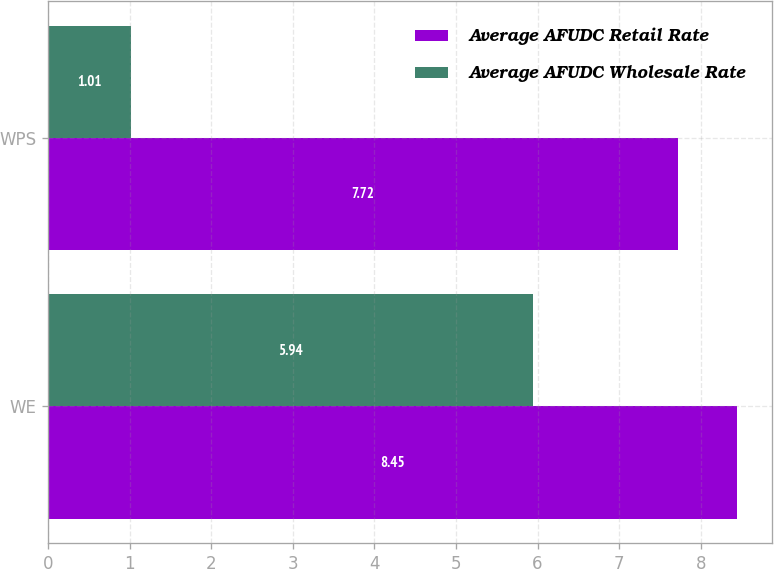<chart> <loc_0><loc_0><loc_500><loc_500><stacked_bar_chart><ecel><fcel>WE<fcel>WPS<nl><fcel>Average AFUDC Retail Rate<fcel>8.45<fcel>7.72<nl><fcel>Average AFUDC Wholesale Rate<fcel>5.94<fcel>1.01<nl></chart> 